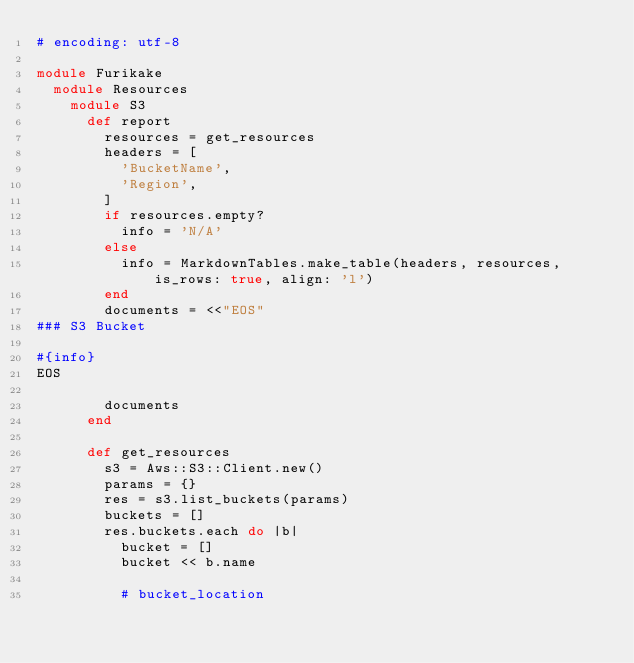<code> <loc_0><loc_0><loc_500><loc_500><_Ruby_># encoding: utf-8

module Furikake
  module Resources
    module S3
      def report
        resources = get_resources
        headers = [
          'BucketName',
          'Region',
        ]
        if resources.empty?
          info = 'N/A'
        else
          info = MarkdownTables.make_table(headers, resources, is_rows: true, align: 'l')
        end
        documents = <<"EOS"
### S3 Bucket

#{info}
EOS
        
        documents
      end

      def get_resources
        s3 = Aws::S3::Client.new()
        params = {}
        res = s3.list_buckets(params)
        buckets = []
        res.buckets.each do |b|
          bucket = []
          bucket << b.name

          # bucket_location</code> 